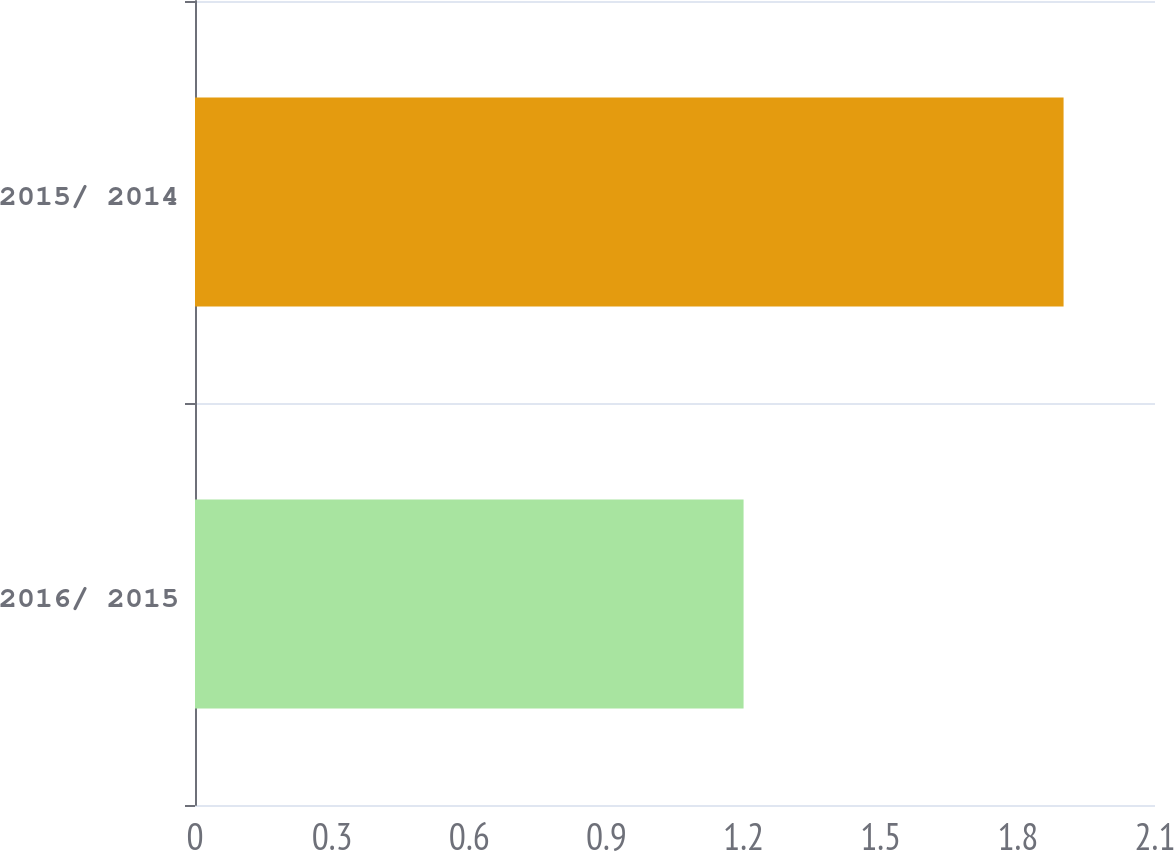Convert chart to OTSL. <chart><loc_0><loc_0><loc_500><loc_500><bar_chart><fcel>2016/ 2015<fcel>2015/ 2014<nl><fcel>1.2<fcel>1.9<nl></chart> 